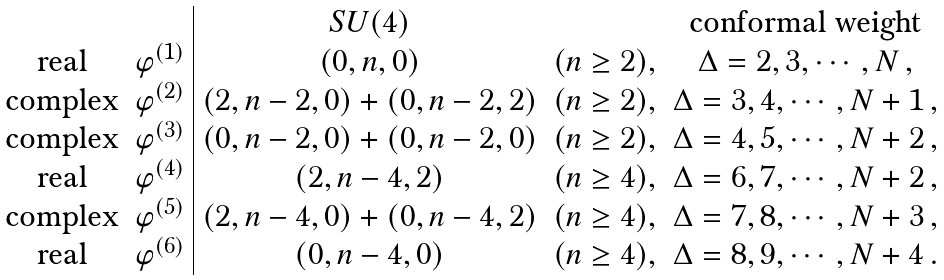Convert formula to latex. <formula><loc_0><loc_0><loc_500><loc_500>\begin{array} { c c | c c c } & & S U ( 4 ) & & \text {conformal weight} \\ \text {real} & \varphi ^ { ( 1 ) } & ( 0 , n , 0 ) & ( n \geq 2 ) , & \Delta = 2 , 3 , \cdots , N \, , \\ \text {complex} & \varphi ^ { ( 2 ) } & ( 2 , n - 2 , 0 ) + ( 0 , n - 2 , 2 ) & ( n \geq 2 ) , & \Delta = 3 , 4 , \cdots , N + 1 \, , \\ \text {complex} & \varphi ^ { ( 3 ) } & ( 0 , n - 2 , 0 ) + ( 0 , n - 2 , 0 ) & ( n \geq 2 ) , & \Delta = 4 , 5 , \cdots , N + 2 \, , \\ \text {real} & \varphi ^ { ( 4 ) } & ( 2 , n - 4 , 2 ) & ( n \geq 4 ) , & \Delta = 6 , 7 , \cdots , N + 2 \, , \\ \text {complex} & \varphi ^ { ( 5 ) } & ( 2 , n - 4 , 0 ) + ( 0 , n - 4 , 2 ) & ( n \geq 4 ) , & \Delta = 7 , 8 , \cdots , N + 3 \, , \\ \text {real} & \varphi ^ { ( 6 ) } & ( 0 , n - 4 , 0 ) & ( n \geq 4 ) , & \Delta = 8 , 9 , \cdots , N + 4 \, . \end{array}</formula> 